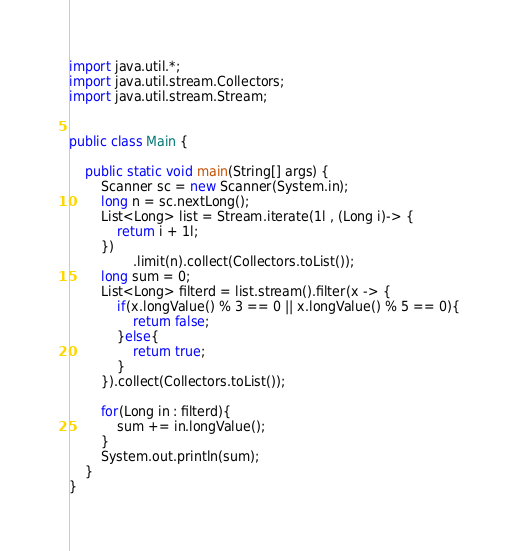Convert code to text. <code><loc_0><loc_0><loc_500><loc_500><_Java_>import java.util.*;
import java.util.stream.Collectors;
import java.util.stream.Stream;


public class Main {

    public static void main(String[] args) {
        Scanner sc = new Scanner(System.in);
        long n = sc.nextLong();
        List<Long> list = Stream.iterate(1l , (Long i)-> {
            return i + 1l;
        })
                .limit(n).collect(Collectors.toList());
        long sum = 0;
        List<Long> filterd = list.stream().filter(x -> {
            if(x.longValue() % 3 == 0 || x.longValue() % 5 == 0){
                return false;
            }else{
                return true;
            }
        }).collect(Collectors.toList());

        for(Long in : filterd){
            sum += in.longValue();
        }
        System.out.println(sum);
    }
}
</code> 